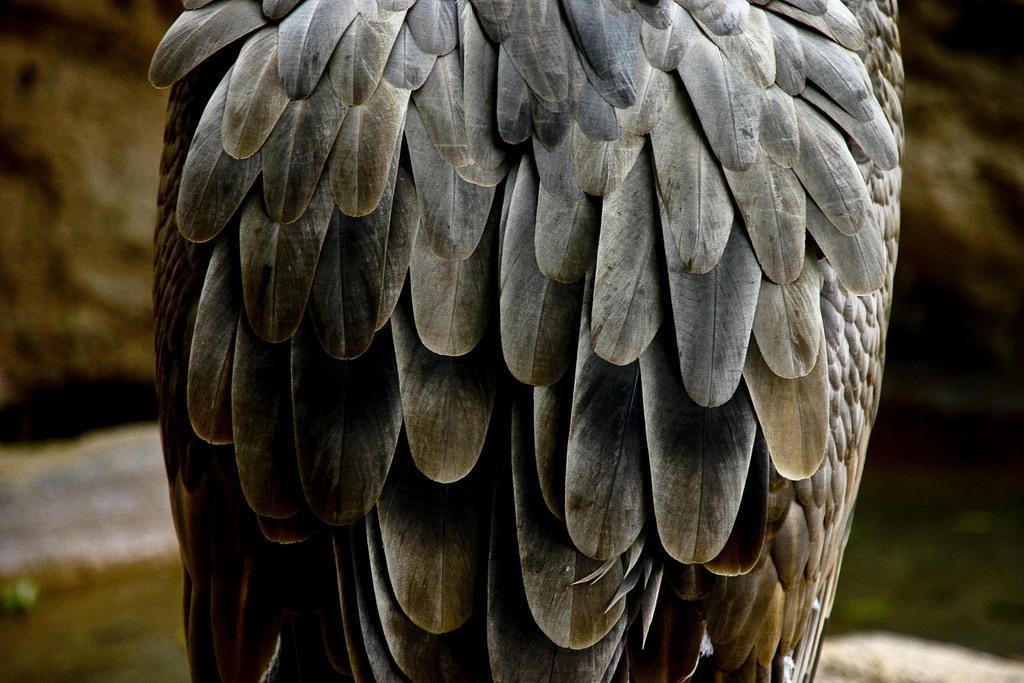In one or two sentences, can you explain what this image depicts? In this image, we can see a bird on blue background. 